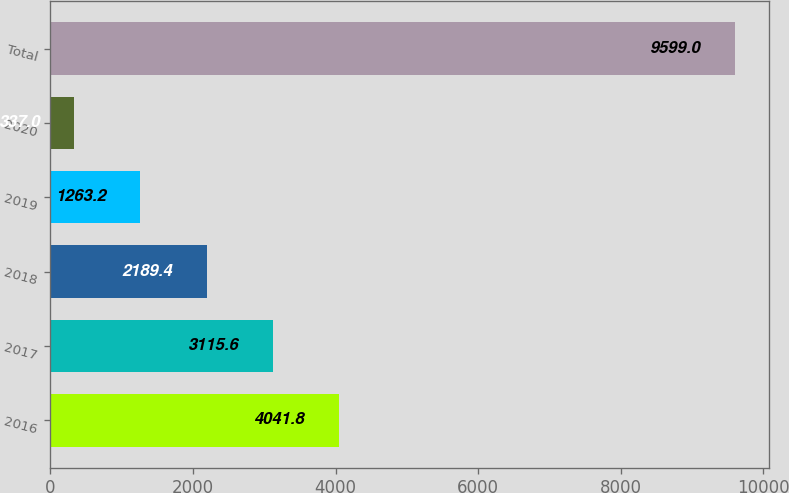Convert chart. <chart><loc_0><loc_0><loc_500><loc_500><bar_chart><fcel>2016<fcel>2017<fcel>2018<fcel>2019<fcel>2020<fcel>Total<nl><fcel>4041.8<fcel>3115.6<fcel>2189.4<fcel>1263.2<fcel>337<fcel>9599<nl></chart> 